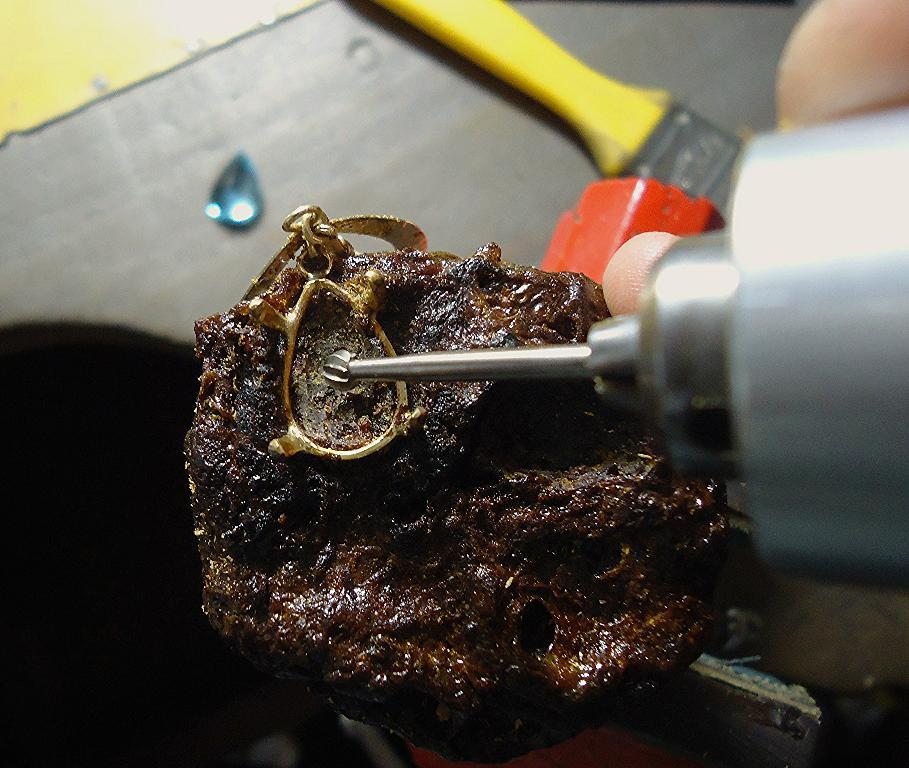What is the person holding in the image? There is an object in a person's hand in the image. Can you identify any specific tools or instruments in the image? Yes, there is a brush in the image. Are there any other objects visible in the image? Yes, there are other unspecified objects in the image. How does the yam contribute to the person's digestion in the image? There is no yam present in the image, so it cannot contribute to the person's digestion. What type of gate is visible in the image? There is no gate present in the image. 